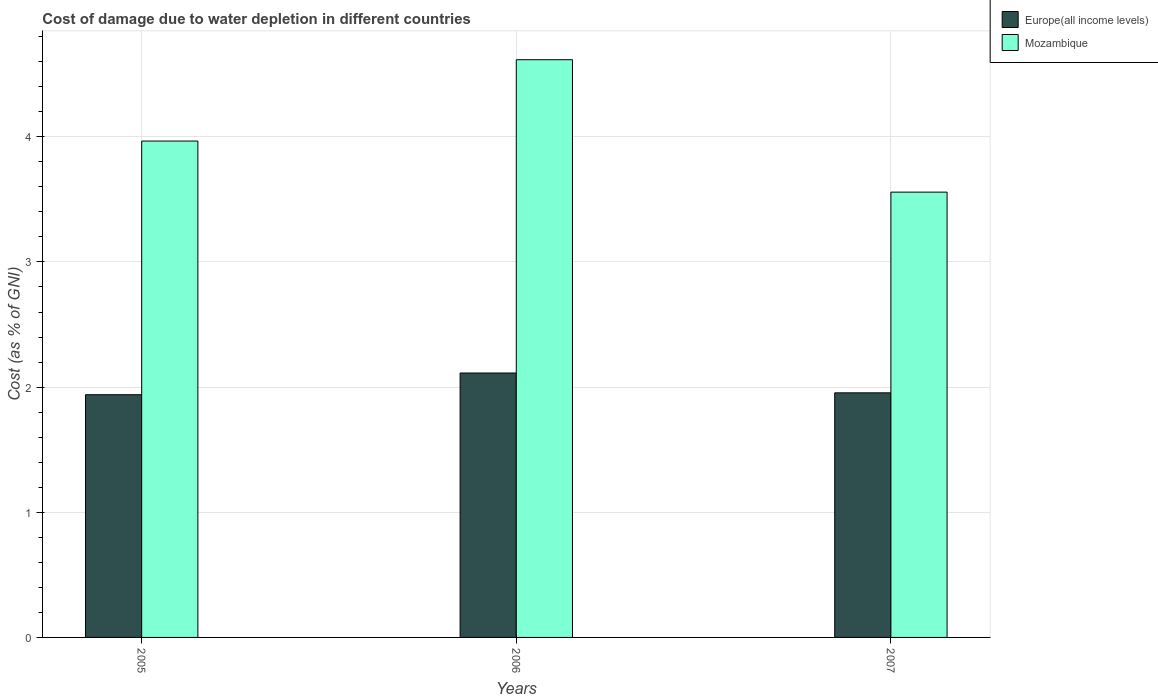How many different coloured bars are there?
Offer a terse response. 2. How many groups of bars are there?
Ensure brevity in your answer.  3. Are the number of bars on each tick of the X-axis equal?
Provide a short and direct response. Yes. How many bars are there on the 1st tick from the right?
Make the answer very short. 2. In how many cases, is the number of bars for a given year not equal to the number of legend labels?
Provide a succinct answer. 0. What is the cost of damage caused due to water depletion in Mozambique in 2007?
Your response must be concise. 3.56. Across all years, what is the maximum cost of damage caused due to water depletion in Mozambique?
Your answer should be compact. 4.62. Across all years, what is the minimum cost of damage caused due to water depletion in Europe(all income levels)?
Give a very brief answer. 1.94. What is the total cost of damage caused due to water depletion in Europe(all income levels) in the graph?
Provide a short and direct response. 6.01. What is the difference between the cost of damage caused due to water depletion in Europe(all income levels) in 2005 and that in 2006?
Provide a succinct answer. -0.17. What is the difference between the cost of damage caused due to water depletion in Europe(all income levels) in 2007 and the cost of damage caused due to water depletion in Mozambique in 2006?
Your response must be concise. -2.66. What is the average cost of damage caused due to water depletion in Europe(all income levels) per year?
Provide a short and direct response. 2. In the year 2006, what is the difference between the cost of damage caused due to water depletion in Mozambique and cost of damage caused due to water depletion in Europe(all income levels)?
Give a very brief answer. 2.5. What is the ratio of the cost of damage caused due to water depletion in Europe(all income levels) in 2005 to that in 2006?
Ensure brevity in your answer.  0.92. What is the difference between the highest and the second highest cost of damage caused due to water depletion in Europe(all income levels)?
Provide a short and direct response. 0.16. What is the difference between the highest and the lowest cost of damage caused due to water depletion in Mozambique?
Make the answer very short. 1.06. Is the sum of the cost of damage caused due to water depletion in Europe(all income levels) in 2005 and 2007 greater than the maximum cost of damage caused due to water depletion in Mozambique across all years?
Your answer should be compact. No. What does the 2nd bar from the left in 2005 represents?
Provide a short and direct response. Mozambique. What does the 2nd bar from the right in 2006 represents?
Ensure brevity in your answer.  Europe(all income levels). Are all the bars in the graph horizontal?
Offer a terse response. No. Are the values on the major ticks of Y-axis written in scientific E-notation?
Your response must be concise. No. Does the graph contain any zero values?
Ensure brevity in your answer.  No. Where does the legend appear in the graph?
Make the answer very short. Top right. How many legend labels are there?
Give a very brief answer. 2. What is the title of the graph?
Provide a succinct answer. Cost of damage due to water depletion in different countries. What is the label or title of the X-axis?
Provide a succinct answer. Years. What is the label or title of the Y-axis?
Make the answer very short. Cost (as % of GNI). What is the Cost (as % of GNI) in Europe(all income levels) in 2005?
Keep it short and to the point. 1.94. What is the Cost (as % of GNI) of Mozambique in 2005?
Give a very brief answer. 3.97. What is the Cost (as % of GNI) in Europe(all income levels) in 2006?
Make the answer very short. 2.11. What is the Cost (as % of GNI) in Mozambique in 2006?
Your answer should be compact. 4.62. What is the Cost (as % of GNI) in Europe(all income levels) in 2007?
Provide a succinct answer. 1.95. What is the Cost (as % of GNI) of Mozambique in 2007?
Keep it short and to the point. 3.56. Across all years, what is the maximum Cost (as % of GNI) in Europe(all income levels)?
Keep it short and to the point. 2.11. Across all years, what is the maximum Cost (as % of GNI) in Mozambique?
Keep it short and to the point. 4.62. Across all years, what is the minimum Cost (as % of GNI) of Europe(all income levels)?
Make the answer very short. 1.94. Across all years, what is the minimum Cost (as % of GNI) of Mozambique?
Give a very brief answer. 3.56. What is the total Cost (as % of GNI) of Europe(all income levels) in the graph?
Your answer should be very brief. 6.01. What is the total Cost (as % of GNI) in Mozambique in the graph?
Provide a succinct answer. 12.14. What is the difference between the Cost (as % of GNI) of Europe(all income levels) in 2005 and that in 2006?
Keep it short and to the point. -0.17. What is the difference between the Cost (as % of GNI) of Mozambique in 2005 and that in 2006?
Give a very brief answer. -0.65. What is the difference between the Cost (as % of GNI) of Europe(all income levels) in 2005 and that in 2007?
Offer a terse response. -0.01. What is the difference between the Cost (as % of GNI) in Mozambique in 2005 and that in 2007?
Your answer should be compact. 0.41. What is the difference between the Cost (as % of GNI) in Europe(all income levels) in 2006 and that in 2007?
Offer a terse response. 0.16. What is the difference between the Cost (as % of GNI) of Mozambique in 2006 and that in 2007?
Ensure brevity in your answer.  1.06. What is the difference between the Cost (as % of GNI) of Europe(all income levels) in 2005 and the Cost (as % of GNI) of Mozambique in 2006?
Provide a short and direct response. -2.68. What is the difference between the Cost (as % of GNI) of Europe(all income levels) in 2005 and the Cost (as % of GNI) of Mozambique in 2007?
Your answer should be very brief. -1.62. What is the difference between the Cost (as % of GNI) in Europe(all income levels) in 2006 and the Cost (as % of GNI) in Mozambique in 2007?
Your answer should be very brief. -1.45. What is the average Cost (as % of GNI) of Europe(all income levels) per year?
Make the answer very short. 2. What is the average Cost (as % of GNI) in Mozambique per year?
Your response must be concise. 4.05. In the year 2005, what is the difference between the Cost (as % of GNI) of Europe(all income levels) and Cost (as % of GNI) of Mozambique?
Keep it short and to the point. -2.03. In the year 2006, what is the difference between the Cost (as % of GNI) in Europe(all income levels) and Cost (as % of GNI) in Mozambique?
Your answer should be very brief. -2.5. In the year 2007, what is the difference between the Cost (as % of GNI) of Europe(all income levels) and Cost (as % of GNI) of Mozambique?
Your response must be concise. -1.6. What is the ratio of the Cost (as % of GNI) in Europe(all income levels) in 2005 to that in 2006?
Ensure brevity in your answer.  0.92. What is the ratio of the Cost (as % of GNI) of Mozambique in 2005 to that in 2006?
Keep it short and to the point. 0.86. What is the ratio of the Cost (as % of GNI) in Mozambique in 2005 to that in 2007?
Your answer should be compact. 1.11. What is the ratio of the Cost (as % of GNI) in Europe(all income levels) in 2006 to that in 2007?
Ensure brevity in your answer.  1.08. What is the ratio of the Cost (as % of GNI) in Mozambique in 2006 to that in 2007?
Offer a terse response. 1.3. What is the difference between the highest and the second highest Cost (as % of GNI) of Europe(all income levels)?
Your response must be concise. 0.16. What is the difference between the highest and the second highest Cost (as % of GNI) of Mozambique?
Provide a succinct answer. 0.65. What is the difference between the highest and the lowest Cost (as % of GNI) of Europe(all income levels)?
Make the answer very short. 0.17. What is the difference between the highest and the lowest Cost (as % of GNI) in Mozambique?
Offer a very short reply. 1.06. 